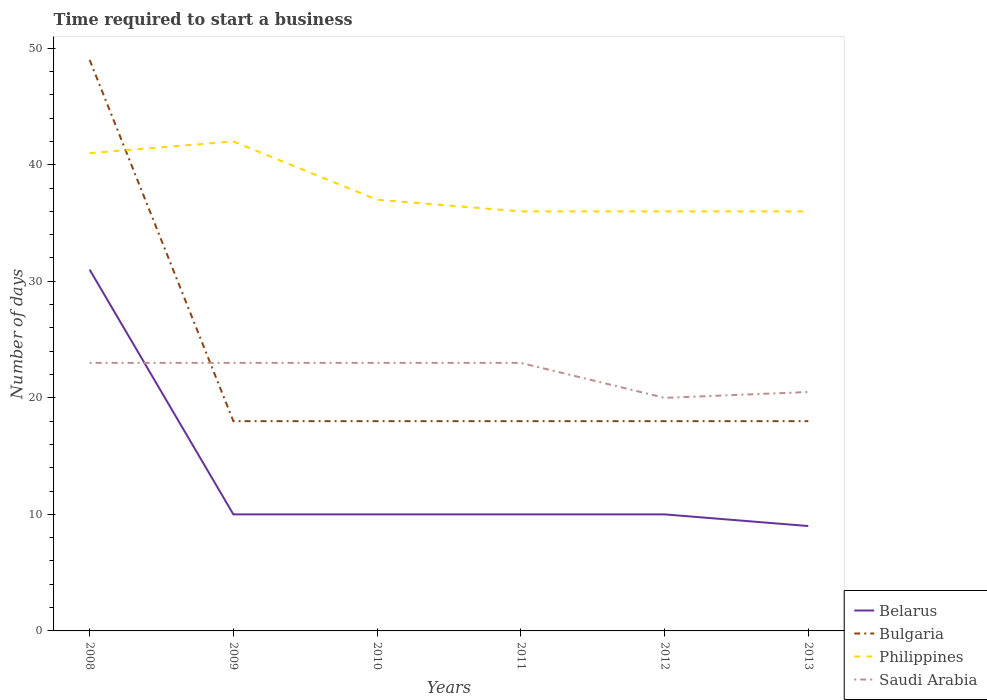How many different coloured lines are there?
Keep it short and to the point. 4. Is the number of lines equal to the number of legend labels?
Provide a short and direct response. Yes. Across all years, what is the maximum number of days required to start a business in Bulgaria?
Keep it short and to the point. 18. In which year was the number of days required to start a business in Saudi Arabia maximum?
Your response must be concise. 2012. Is the number of days required to start a business in Belarus strictly greater than the number of days required to start a business in Bulgaria over the years?
Provide a succinct answer. Yes. How many years are there in the graph?
Your answer should be compact. 6. Are the values on the major ticks of Y-axis written in scientific E-notation?
Offer a terse response. No. Does the graph contain any zero values?
Provide a succinct answer. No. Does the graph contain grids?
Your answer should be very brief. No. How are the legend labels stacked?
Ensure brevity in your answer.  Vertical. What is the title of the graph?
Make the answer very short. Time required to start a business. Does "Pacific island small states" appear as one of the legend labels in the graph?
Your answer should be very brief. No. What is the label or title of the Y-axis?
Provide a succinct answer. Number of days. What is the Number of days of Belarus in 2008?
Make the answer very short. 31. What is the Number of days of Philippines in 2008?
Provide a short and direct response. 41. What is the Number of days in Saudi Arabia in 2008?
Your answer should be very brief. 23. What is the Number of days in Philippines in 2009?
Offer a terse response. 42. What is the Number of days of Belarus in 2010?
Give a very brief answer. 10. What is the Number of days of Bulgaria in 2010?
Your response must be concise. 18. What is the Number of days in Belarus in 2011?
Ensure brevity in your answer.  10. What is the Number of days of Saudi Arabia in 2011?
Your response must be concise. 23. What is the Number of days of Philippines in 2012?
Your answer should be compact. 36. What is the Number of days in Saudi Arabia in 2012?
Make the answer very short. 20. What is the Number of days in Saudi Arabia in 2013?
Offer a terse response. 20.5. Across all years, what is the maximum Number of days of Bulgaria?
Offer a very short reply. 49. Across all years, what is the maximum Number of days of Philippines?
Ensure brevity in your answer.  42. Across all years, what is the minimum Number of days in Belarus?
Provide a succinct answer. 9. Across all years, what is the minimum Number of days in Bulgaria?
Provide a succinct answer. 18. Across all years, what is the minimum Number of days of Philippines?
Provide a short and direct response. 36. Across all years, what is the minimum Number of days in Saudi Arabia?
Your answer should be very brief. 20. What is the total Number of days of Belarus in the graph?
Offer a very short reply. 80. What is the total Number of days of Bulgaria in the graph?
Make the answer very short. 139. What is the total Number of days in Philippines in the graph?
Keep it short and to the point. 228. What is the total Number of days of Saudi Arabia in the graph?
Provide a short and direct response. 132.5. What is the difference between the Number of days in Belarus in 2008 and that in 2009?
Your answer should be very brief. 21. What is the difference between the Number of days of Bulgaria in 2008 and that in 2009?
Your answer should be compact. 31. What is the difference between the Number of days of Philippines in 2008 and that in 2009?
Your answer should be very brief. -1. What is the difference between the Number of days in Saudi Arabia in 2008 and that in 2010?
Offer a terse response. 0. What is the difference between the Number of days in Belarus in 2008 and that in 2011?
Ensure brevity in your answer.  21. What is the difference between the Number of days in Bulgaria in 2008 and that in 2011?
Make the answer very short. 31. What is the difference between the Number of days of Philippines in 2008 and that in 2011?
Ensure brevity in your answer.  5. What is the difference between the Number of days in Saudi Arabia in 2008 and that in 2011?
Keep it short and to the point. 0. What is the difference between the Number of days in Belarus in 2008 and that in 2012?
Keep it short and to the point. 21. What is the difference between the Number of days in Saudi Arabia in 2008 and that in 2012?
Give a very brief answer. 3. What is the difference between the Number of days in Belarus in 2009 and that in 2010?
Ensure brevity in your answer.  0. What is the difference between the Number of days in Bulgaria in 2009 and that in 2010?
Keep it short and to the point. 0. What is the difference between the Number of days in Belarus in 2009 and that in 2011?
Provide a succinct answer. 0. What is the difference between the Number of days in Philippines in 2009 and that in 2011?
Your response must be concise. 6. What is the difference between the Number of days in Saudi Arabia in 2009 and that in 2011?
Offer a terse response. 0. What is the difference between the Number of days of Belarus in 2009 and that in 2012?
Give a very brief answer. 0. What is the difference between the Number of days in Philippines in 2009 and that in 2012?
Your answer should be very brief. 6. What is the difference between the Number of days in Belarus in 2009 and that in 2013?
Give a very brief answer. 1. What is the difference between the Number of days in Belarus in 2010 and that in 2011?
Your answer should be very brief. 0. What is the difference between the Number of days in Bulgaria in 2010 and that in 2011?
Your answer should be very brief. 0. What is the difference between the Number of days in Belarus in 2010 and that in 2012?
Give a very brief answer. 0. What is the difference between the Number of days in Bulgaria in 2010 and that in 2012?
Keep it short and to the point. 0. What is the difference between the Number of days in Philippines in 2010 and that in 2012?
Provide a succinct answer. 1. What is the difference between the Number of days of Bulgaria in 2010 and that in 2013?
Provide a short and direct response. 0. What is the difference between the Number of days in Philippines in 2010 and that in 2013?
Your response must be concise. 1. What is the difference between the Number of days in Belarus in 2011 and that in 2013?
Provide a short and direct response. 1. What is the difference between the Number of days of Philippines in 2011 and that in 2013?
Give a very brief answer. 0. What is the difference between the Number of days of Saudi Arabia in 2011 and that in 2013?
Make the answer very short. 2.5. What is the difference between the Number of days of Belarus in 2012 and that in 2013?
Your answer should be very brief. 1. What is the difference between the Number of days in Belarus in 2008 and the Number of days in Saudi Arabia in 2009?
Give a very brief answer. 8. What is the difference between the Number of days in Bulgaria in 2008 and the Number of days in Philippines in 2009?
Your answer should be compact. 7. What is the difference between the Number of days of Philippines in 2008 and the Number of days of Saudi Arabia in 2009?
Provide a short and direct response. 18. What is the difference between the Number of days of Belarus in 2008 and the Number of days of Saudi Arabia in 2010?
Your response must be concise. 8. What is the difference between the Number of days of Bulgaria in 2008 and the Number of days of Philippines in 2010?
Keep it short and to the point. 12. What is the difference between the Number of days of Bulgaria in 2008 and the Number of days of Saudi Arabia in 2010?
Make the answer very short. 26. What is the difference between the Number of days of Belarus in 2008 and the Number of days of Bulgaria in 2012?
Keep it short and to the point. 13. What is the difference between the Number of days in Belarus in 2008 and the Number of days in Philippines in 2012?
Give a very brief answer. -5. What is the difference between the Number of days of Bulgaria in 2008 and the Number of days of Saudi Arabia in 2012?
Keep it short and to the point. 29. What is the difference between the Number of days of Philippines in 2008 and the Number of days of Saudi Arabia in 2012?
Make the answer very short. 21. What is the difference between the Number of days of Belarus in 2008 and the Number of days of Philippines in 2013?
Your answer should be compact. -5. What is the difference between the Number of days in Belarus in 2008 and the Number of days in Saudi Arabia in 2013?
Your answer should be very brief. 10.5. What is the difference between the Number of days in Bulgaria in 2008 and the Number of days in Saudi Arabia in 2013?
Offer a terse response. 28.5. What is the difference between the Number of days of Belarus in 2009 and the Number of days of Bulgaria in 2010?
Offer a very short reply. -8. What is the difference between the Number of days of Belarus in 2009 and the Number of days of Philippines in 2010?
Offer a very short reply. -27. What is the difference between the Number of days in Belarus in 2009 and the Number of days in Saudi Arabia in 2010?
Make the answer very short. -13. What is the difference between the Number of days in Bulgaria in 2009 and the Number of days in Philippines in 2010?
Ensure brevity in your answer.  -19. What is the difference between the Number of days of Belarus in 2009 and the Number of days of Philippines in 2011?
Make the answer very short. -26. What is the difference between the Number of days of Belarus in 2009 and the Number of days of Saudi Arabia in 2011?
Provide a short and direct response. -13. What is the difference between the Number of days of Bulgaria in 2009 and the Number of days of Philippines in 2011?
Keep it short and to the point. -18. What is the difference between the Number of days of Bulgaria in 2009 and the Number of days of Saudi Arabia in 2011?
Give a very brief answer. -5. What is the difference between the Number of days in Belarus in 2009 and the Number of days in Bulgaria in 2012?
Keep it short and to the point. -8. What is the difference between the Number of days in Belarus in 2009 and the Number of days in Philippines in 2012?
Your response must be concise. -26. What is the difference between the Number of days of Belarus in 2009 and the Number of days of Saudi Arabia in 2012?
Provide a succinct answer. -10. What is the difference between the Number of days in Bulgaria in 2009 and the Number of days in Philippines in 2012?
Make the answer very short. -18. What is the difference between the Number of days in Philippines in 2009 and the Number of days in Saudi Arabia in 2012?
Offer a terse response. 22. What is the difference between the Number of days in Belarus in 2009 and the Number of days in Philippines in 2013?
Offer a very short reply. -26. What is the difference between the Number of days of Belarus in 2009 and the Number of days of Saudi Arabia in 2013?
Your answer should be very brief. -10.5. What is the difference between the Number of days in Bulgaria in 2009 and the Number of days in Saudi Arabia in 2013?
Offer a very short reply. -2.5. What is the difference between the Number of days of Philippines in 2009 and the Number of days of Saudi Arabia in 2013?
Provide a succinct answer. 21.5. What is the difference between the Number of days of Belarus in 2010 and the Number of days of Bulgaria in 2011?
Provide a short and direct response. -8. What is the difference between the Number of days in Belarus in 2010 and the Number of days in Philippines in 2011?
Offer a terse response. -26. What is the difference between the Number of days in Belarus in 2010 and the Number of days in Saudi Arabia in 2011?
Ensure brevity in your answer.  -13. What is the difference between the Number of days of Bulgaria in 2010 and the Number of days of Philippines in 2011?
Offer a terse response. -18. What is the difference between the Number of days of Bulgaria in 2010 and the Number of days of Saudi Arabia in 2011?
Keep it short and to the point. -5. What is the difference between the Number of days in Philippines in 2010 and the Number of days in Saudi Arabia in 2011?
Provide a short and direct response. 14. What is the difference between the Number of days in Belarus in 2010 and the Number of days in Philippines in 2012?
Give a very brief answer. -26. What is the difference between the Number of days of Bulgaria in 2010 and the Number of days of Saudi Arabia in 2012?
Ensure brevity in your answer.  -2. What is the difference between the Number of days of Belarus in 2010 and the Number of days of Saudi Arabia in 2013?
Give a very brief answer. -10.5. What is the difference between the Number of days of Bulgaria in 2010 and the Number of days of Philippines in 2013?
Keep it short and to the point. -18. What is the difference between the Number of days of Philippines in 2010 and the Number of days of Saudi Arabia in 2013?
Give a very brief answer. 16.5. What is the difference between the Number of days in Belarus in 2011 and the Number of days in Saudi Arabia in 2012?
Provide a short and direct response. -10. What is the difference between the Number of days in Bulgaria in 2011 and the Number of days in Philippines in 2012?
Your answer should be very brief. -18. What is the difference between the Number of days in Bulgaria in 2011 and the Number of days in Saudi Arabia in 2012?
Your answer should be very brief. -2. What is the difference between the Number of days of Belarus in 2011 and the Number of days of Philippines in 2013?
Offer a very short reply. -26. What is the difference between the Number of days in Bulgaria in 2011 and the Number of days in Saudi Arabia in 2013?
Provide a succinct answer. -2.5. What is the difference between the Number of days of Philippines in 2011 and the Number of days of Saudi Arabia in 2013?
Provide a succinct answer. 15.5. What is the difference between the Number of days of Belarus in 2012 and the Number of days of Bulgaria in 2013?
Offer a terse response. -8. What is the difference between the Number of days of Belarus in 2012 and the Number of days of Philippines in 2013?
Provide a succinct answer. -26. What is the average Number of days in Belarus per year?
Ensure brevity in your answer.  13.33. What is the average Number of days of Bulgaria per year?
Your answer should be compact. 23.17. What is the average Number of days in Philippines per year?
Keep it short and to the point. 38. What is the average Number of days in Saudi Arabia per year?
Offer a very short reply. 22.08. In the year 2008, what is the difference between the Number of days of Belarus and Number of days of Bulgaria?
Your answer should be very brief. -18. In the year 2009, what is the difference between the Number of days in Belarus and Number of days in Philippines?
Your answer should be very brief. -32. In the year 2009, what is the difference between the Number of days of Belarus and Number of days of Saudi Arabia?
Provide a succinct answer. -13. In the year 2009, what is the difference between the Number of days in Bulgaria and Number of days in Philippines?
Offer a terse response. -24. In the year 2009, what is the difference between the Number of days in Bulgaria and Number of days in Saudi Arabia?
Keep it short and to the point. -5. In the year 2009, what is the difference between the Number of days in Philippines and Number of days in Saudi Arabia?
Provide a succinct answer. 19. In the year 2010, what is the difference between the Number of days of Belarus and Number of days of Bulgaria?
Your answer should be compact. -8. In the year 2010, what is the difference between the Number of days of Belarus and Number of days of Saudi Arabia?
Your answer should be compact. -13. In the year 2010, what is the difference between the Number of days in Philippines and Number of days in Saudi Arabia?
Make the answer very short. 14. In the year 2011, what is the difference between the Number of days of Belarus and Number of days of Philippines?
Your answer should be compact. -26. In the year 2011, what is the difference between the Number of days of Belarus and Number of days of Saudi Arabia?
Your response must be concise. -13. In the year 2011, what is the difference between the Number of days in Bulgaria and Number of days in Saudi Arabia?
Your answer should be compact. -5. In the year 2012, what is the difference between the Number of days of Belarus and Number of days of Saudi Arabia?
Your response must be concise. -10. In the year 2012, what is the difference between the Number of days in Bulgaria and Number of days in Philippines?
Your answer should be very brief. -18. In the year 2012, what is the difference between the Number of days of Bulgaria and Number of days of Saudi Arabia?
Ensure brevity in your answer.  -2. In the year 2013, what is the difference between the Number of days of Belarus and Number of days of Bulgaria?
Offer a very short reply. -9. In the year 2013, what is the difference between the Number of days in Belarus and Number of days in Philippines?
Your answer should be very brief. -27. In the year 2013, what is the difference between the Number of days in Belarus and Number of days in Saudi Arabia?
Ensure brevity in your answer.  -11.5. In the year 2013, what is the difference between the Number of days in Bulgaria and Number of days in Philippines?
Your response must be concise. -18. In the year 2013, what is the difference between the Number of days of Bulgaria and Number of days of Saudi Arabia?
Your answer should be compact. -2.5. In the year 2013, what is the difference between the Number of days in Philippines and Number of days in Saudi Arabia?
Ensure brevity in your answer.  15.5. What is the ratio of the Number of days in Belarus in 2008 to that in 2009?
Offer a very short reply. 3.1. What is the ratio of the Number of days in Bulgaria in 2008 to that in 2009?
Provide a succinct answer. 2.72. What is the ratio of the Number of days of Philippines in 2008 to that in 2009?
Provide a short and direct response. 0.98. What is the ratio of the Number of days in Belarus in 2008 to that in 2010?
Provide a succinct answer. 3.1. What is the ratio of the Number of days of Bulgaria in 2008 to that in 2010?
Provide a succinct answer. 2.72. What is the ratio of the Number of days of Philippines in 2008 to that in 2010?
Keep it short and to the point. 1.11. What is the ratio of the Number of days in Saudi Arabia in 2008 to that in 2010?
Provide a short and direct response. 1. What is the ratio of the Number of days of Belarus in 2008 to that in 2011?
Ensure brevity in your answer.  3.1. What is the ratio of the Number of days in Bulgaria in 2008 to that in 2011?
Keep it short and to the point. 2.72. What is the ratio of the Number of days in Philippines in 2008 to that in 2011?
Ensure brevity in your answer.  1.14. What is the ratio of the Number of days in Saudi Arabia in 2008 to that in 2011?
Offer a very short reply. 1. What is the ratio of the Number of days of Bulgaria in 2008 to that in 2012?
Your response must be concise. 2.72. What is the ratio of the Number of days in Philippines in 2008 to that in 2012?
Your answer should be very brief. 1.14. What is the ratio of the Number of days of Saudi Arabia in 2008 to that in 2012?
Ensure brevity in your answer.  1.15. What is the ratio of the Number of days in Belarus in 2008 to that in 2013?
Ensure brevity in your answer.  3.44. What is the ratio of the Number of days in Bulgaria in 2008 to that in 2013?
Offer a very short reply. 2.72. What is the ratio of the Number of days in Philippines in 2008 to that in 2013?
Offer a terse response. 1.14. What is the ratio of the Number of days of Saudi Arabia in 2008 to that in 2013?
Provide a short and direct response. 1.12. What is the ratio of the Number of days of Belarus in 2009 to that in 2010?
Your answer should be compact. 1. What is the ratio of the Number of days of Philippines in 2009 to that in 2010?
Offer a terse response. 1.14. What is the ratio of the Number of days of Philippines in 2009 to that in 2011?
Provide a short and direct response. 1.17. What is the ratio of the Number of days of Belarus in 2009 to that in 2012?
Keep it short and to the point. 1. What is the ratio of the Number of days of Bulgaria in 2009 to that in 2012?
Offer a terse response. 1. What is the ratio of the Number of days in Philippines in 2009 to that in 2012?
Your answer should be compact. 1.17. What is the ratio of the Number of days in Saudi Arabia in 2009 to that in 2012?
Your response must be concise. 1.15. What is the ratio of the Number of days in Bulgaria in 2009 to that in 2013?
Offer a terse response. 1. What is the ratio of the Number of days of Philippines in 2009 to that in 2013?
Give a very brief answer. 1.17. What is the ratio of the Number of days of Saudi Arabia in 2009 to that in 2013?
Provide a short and direct response. 1.12. What is the ratio of the Number of days in Philippines in 2010 to that in 2011?
Make the answer very short. 1.03. What is the ratio of the Number of days in Belarus in 2010 to that in 2012?
Ensure brevity in your answer.  1. What is the ratio of the Number of days in Philippines in 2010 to that in 2012?
Offer a very short reply. 1.03. What is the ratio of the Number of days in Saudi Arabia in 2010 to that in 2012?
Your response must be concise. 1.15. What is the ratio of the Number of days of Philippines in 2010 to that in 2013?
Offer a very short reply. 1.03. What is the ratio of the Number of days in Saudi Arabia in 2010 to that in 2013?
Offer a terse response. 1.12. What is the ratio of the Number of days of Belarus in 2011 to that in 2012?
Your response must be concise. 1. What is the ratio of the Number of days in Bulgaria in 2011 to that in 2012?
Ensure brevity in your answer.  1. What is the ratio of the Number of days in Saudi Arabia in 2011 to that in 2012?
Your response must be concise. 1.15. What is the ratio of the Number of days of Belarus in 2011 to that in 2013?
Make the answer very short. 1.11. What is the ratio of the Number of days of Saudi Arabia in 2011 to that in 2013?
Your answer should be very brief. 1.12. What is the ratio of the Number of days in Saudi Arabia in 2012 to that in 2013?
Provide a short and direct response. 0.98. What is the difference between the highest and the second highest Number of days of Bulgaria?
Give a very brief answer. 31. What is the difference between the highest and the second highest Number of days of Philippines?
Your answer should be compact. 1. What is the difference between the highest and the second highest Number of days in Saudi Arabia?
Offer a terse response. 0. What is the difference between the highest and the lowest Number of days in Bulgaria?
Your response must be concise. 31. 